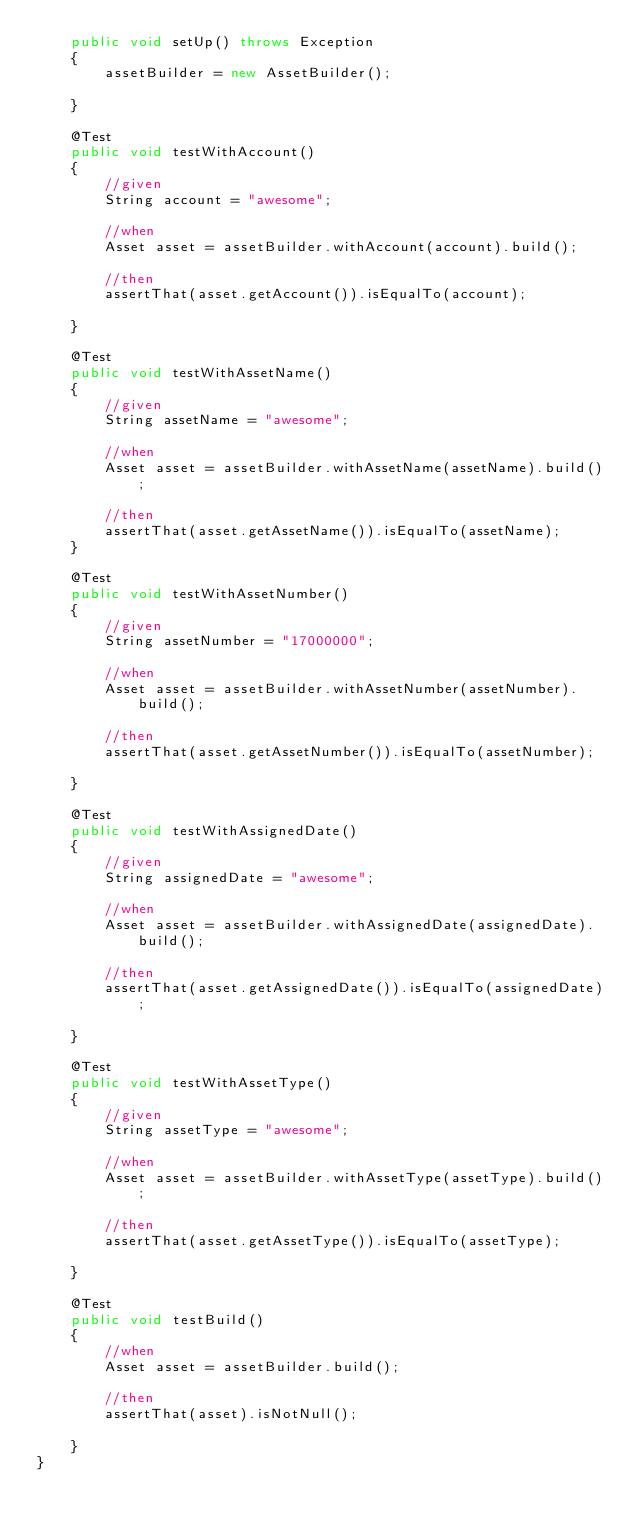<code> <loc_0><loc_0><loc_500><loc_500><_Java_>    public void setUp() throws Exception
    {
        assetBuilder = new AssetBuilder();

    }

    @Test
    public void testWithAccount()
    {
        //given
        String account = "awesome";

        //when
        Asset asset = assetBuilder.withAccount(account).build();

        //then
        assertThat(asset.getAccount()).isEqualTo(account);

    }

    @Test
    public void testWithAssetName()
    {
        //given
        String assetName = "awesome";

        //when
        Asset asset = assetBuilder.withAssetName(assetName).build();

        //then
        assertThat(asset.getAssetName()).isEqualTo(assetName);
    }

    @Test
    public void testWithAssetNumber()
    {
        //given
        String assetNumber = "17000000";

        //when
        Asset asset = assetBuilder.withAssetNumber(assetNumber).build();

        //then
        assertThat(asset.getAssetNumber()).isEqualTo(assetNumber);

    }

    @Test
    public void testWithAssignedDate()
    {
        //given
        String assignedDate = "awesome";

        //when
        Asset asset = assetBuilder.withAssignedDate(assignedDate).build();

        //then
        assertThat(asset.getAssignedDate()).isEqualTo(assignedDate);

    }

    @Test
    public void testWithAssetType()
    {
        //given
        String assetType = "awesome";

        //when
        Asset asset = assetBuilder.withAssetType(assetType).build();

        //then
        assertThat(asset.getAssetType()).isEqualTo(assetType);

    }

    @Test
    public void testBuild()
    {
        //when
        Asset asset = assetBuilder.build();

        //then
        assertThat(asset).isNotNull();

    }
}</code> 